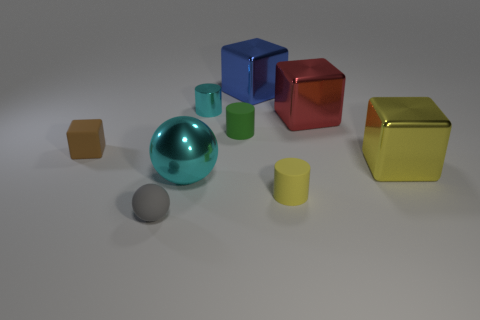What number of things are either large cyan metallic objects or green matte cylinders? The image displays a total of two objects that fit the description: one large cyan metallic sphere and one green matte cylinder. 